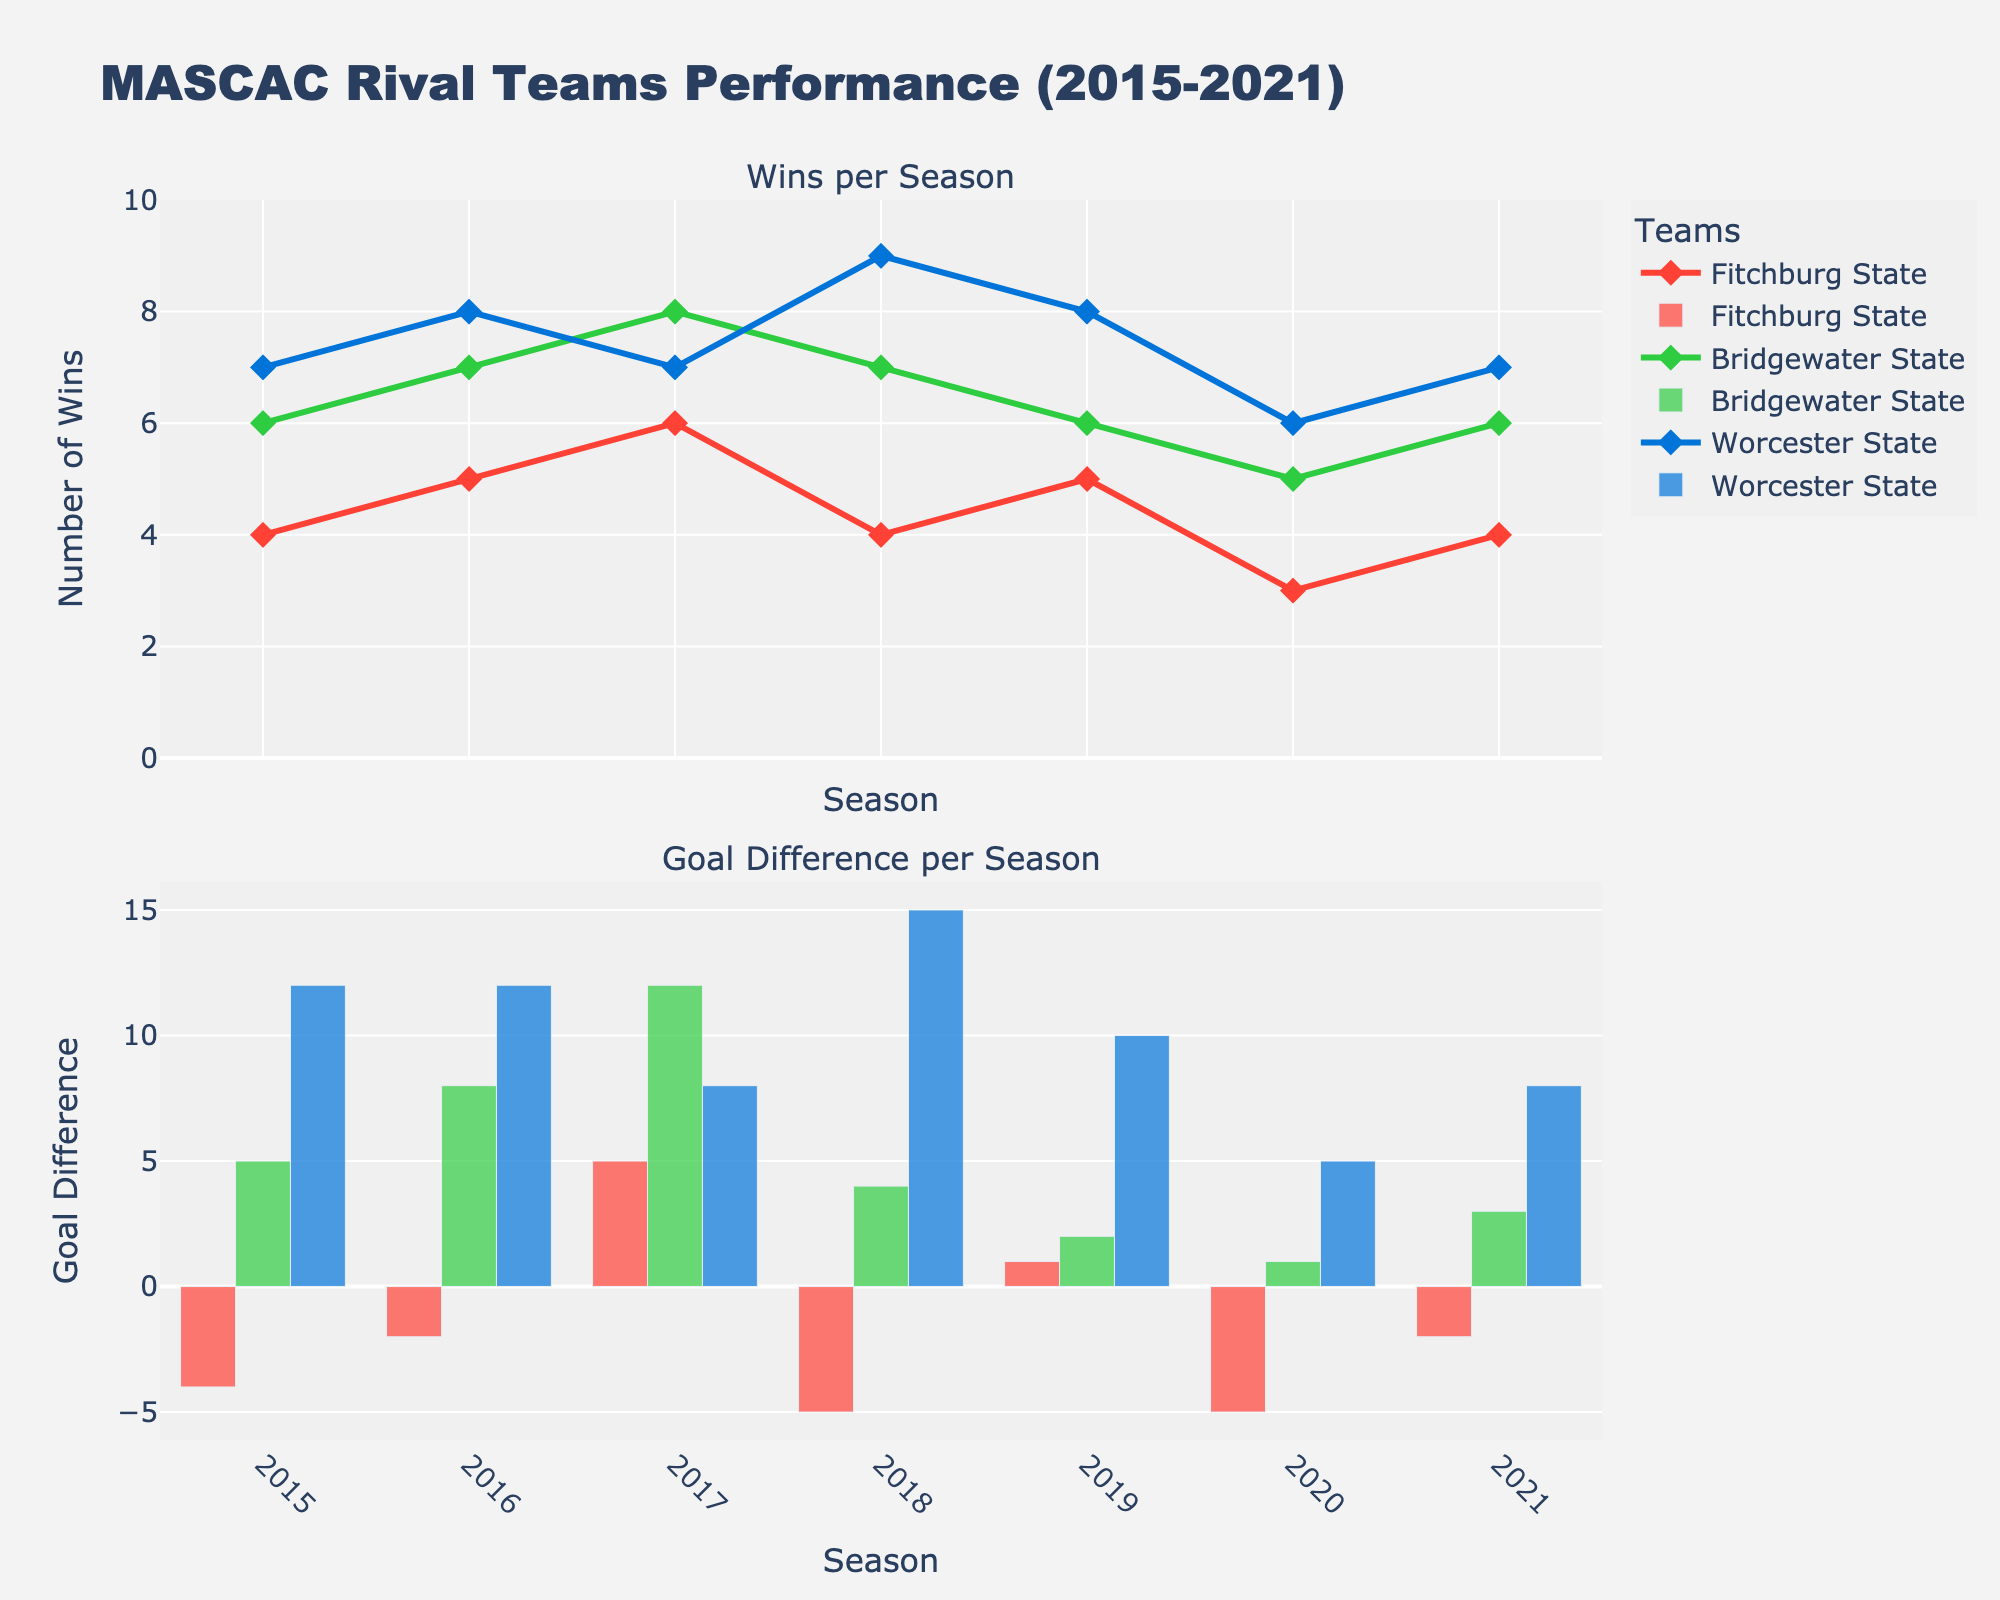What is the title of the figure? The title is typically displayed at the top of the figure. In this case, it reads "MASCAC Rival Teams Performance (2015-2021)".
Answer: MASCAC Rival Teams Performance (2015-2021) Which team had the most wins in 2018? To determine this, look at the "Wins per Season" plot for the year 2018. The team with the highest point on the y-axis indicates the most wins.
Answer: Worcester State What is the goal difference for Fitchburg State in 2016? The goal difference is the number of goals scored minus the number of goals conceded. For Fitchburg State in 2016, consult the "Goal Difference per Season" plot in the second row.
Answer: -2 Which team showed the most consistent performance in terms of wins from 2015 to 2021? Consistency can be evaluated by the variability in the number of wins across seasons. Look for the team whose plot line in the "Wins per Season" graph is the flattest.
Answer: Worcester State Did Bridgewater State's goal difference improve or worsen from 2019 to 2020? To answer this, compare the goal difference bars for Bridgewater State in 2019 and 2020 in the "Goal Difference per Season" plot.
Answer: Worsen Which season had the highest overall goal difference for Worcester State? Identify the tallest bar for Worcester State in the "Goal Difference per Season" plot to find the season with the highest goal difference.
Answer: 2018 Between 2015 and 2021, which year had the smallest difference in wins among all three teams? To find this, observe the "Wins per Season" plot and note the year with the closest values for all three teams.
Answer: 2015 How did the number of wins for Fitchburg State change from 2020 to 2021? Look at Fitchburg State’s data points in the "Wins per Season" plot between 2020 and 2021 to note any increase or decrease.
Answer: Increased What is the average goal difference for Bridgewater State over the entire period? Calculate the goal difference for each season from 2015 to 2021, sum them up, and then divide by the number of seasons.
Answer: 3.28 Which team had the largest increase in wins from one season to the next, and in which season did this occur? Examine all teams' wins across seasons in the "Wins per Season" plot and identify the season with the largest jump.
Answer: Worcester State from 2018 to 2019 